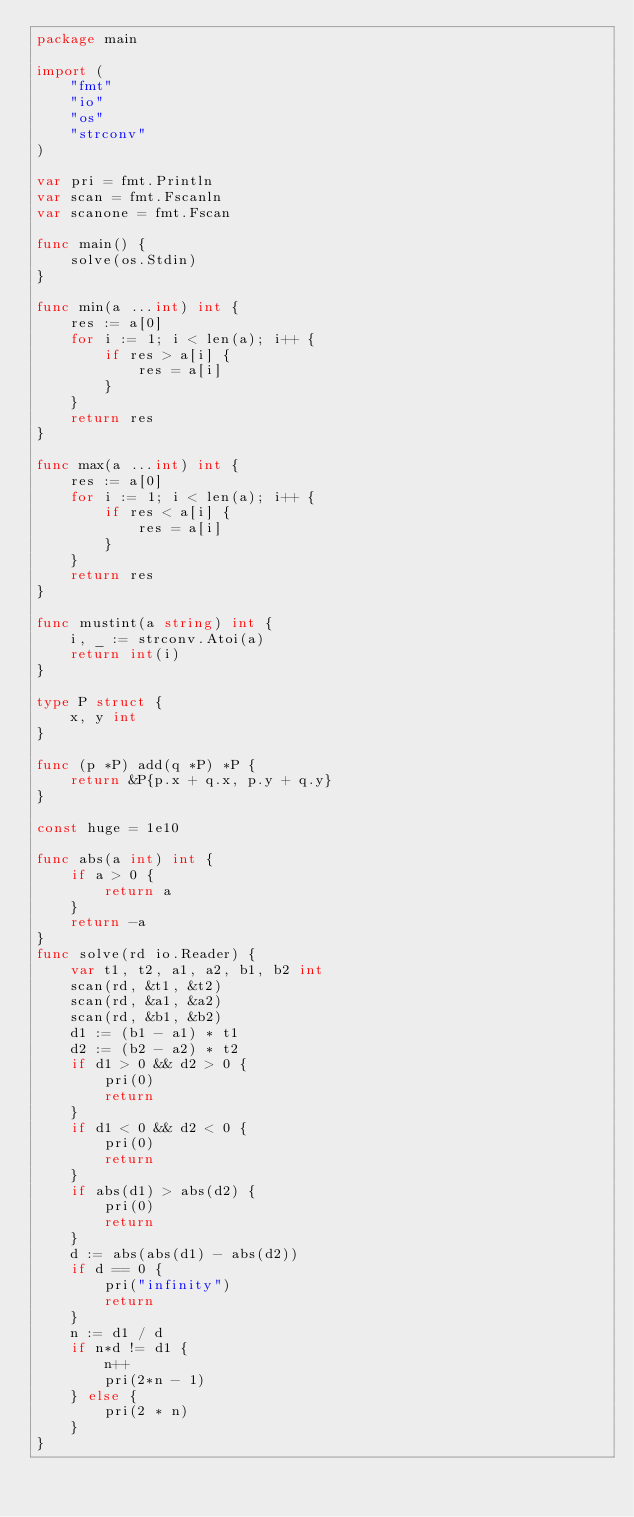Convert code to text. <code><loc_0><loc_0><loc_500><loc_500><_Go_>package main

import (
	"fmt"
	"io"
	"os"
	"strconv"
)

var pri = fmt.Println
var scan = fmt.Fscanln
var scanone = fmt.Fscan

func main() {
	solve(os.Stdin)
}

func min(a ...int) int {
	res := a[0]
	for i := 1; i < len(a); i++ {
		if res > a[i] {
			res = a[i]
		}
	}
	return res
}

func max(a ...int) int {
	res := a[0]
	for i := 1; i < len(a); i++ {
		if res < a[i] {
			res = a[i]
		}
	}
	return res
}

func mustint(a string) int {
	i, _ := strconv.Atoi(a)
	return int(i)
}

type P struct {
	x, y int
}

func (p *P) add(q *P) *P {
	return &P{p.x + q.x, p.y + q.y}
}

const huge = 1e10

func abs(a int) int {
	if a > 0 {
		return a
	}
	return -a
}
func solve(rd io.Reader) {
	var t1, t2, a1, a2, b1, b2 int
	scan(rd, &t1, &t2)
	scan(rd, &a1, &a2)
	scan(rd, &b1, &b2)
	d1 := (b1 - a1) * t1
	d2 := (b2 - a2) * t2
	if d1 > 0 && d2 > 0 {
		pri(0)
		return
	}
	if d1 < 0 && d2 < 0 {
		pri(0)
		return
	}
	if abs(d1) > abs(d2) {
		pri(0)
		return
	}
	d := abs(abs(d1) - abs(d2))
	if d == 0 {
		pri("infinity")
		return
	}
	n := d1 / d
	if n*d != d1 {
		n++
		pri(2*n - 1)
	} else {
		pri(2 * n)
	}
}
</code> 